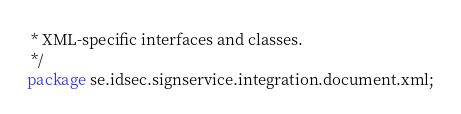Convert code to text. <code><loc_0><loc_0><loc_500><loc_500><_Java_> * XML-specific interfaces and classes.
 */
package se.idsec.signservice.integration.document.xml;</code> 